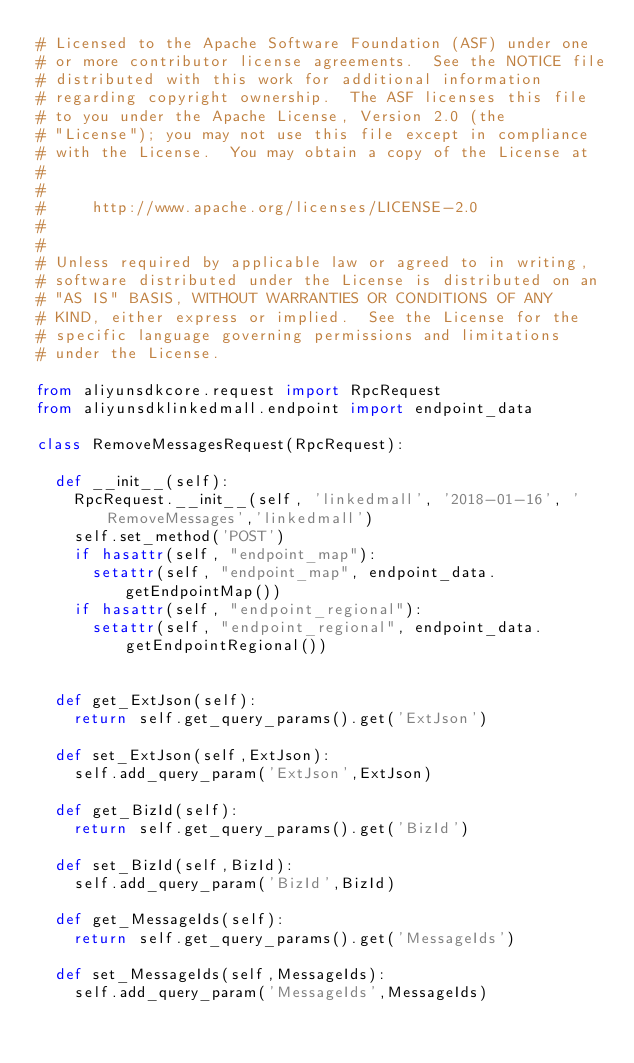<code> <loc_0><loc_0><loc_500><loc_500><_Python_># Licensed to the Apache Software Foundation (ASF) under one
# or more contributor license agreements.  See the NOTICE file
# distributed with this work for additional information
# regarding copyright ownership.  The ASF licenses this file
# to you under the Apache License, Version 2.0 (the
# "License"); you may not use this file except in compliance
# with the License.  You may obtain a copy of the License at
#
#
#     http://www.apache.org/licenses/LICENSE-2.0
#
#
# Unless required by applicable law or agreed to in writing,
# software distributed under the License is distributed on an
# "AS IS" BASIS, WITHOUT WARRANTIES OR CONDITIONS OF ANY
# KIND, either express or implied.  See the License for the
# specific language governing permissions and limitations
# under the License.

from aliyunsdkcore.request import RpcRequest
from aliyunsdklinkedmall.endpoint import endpoint_data

class RemoveMessagesRequest(RpcRequest):

	def __init__(self):
		RpcRequest.__init__(self, 'linkedmall', '2018-01-16', 'RemoveMessages','linkedmall')
		self.set_method('POST')
		if hasattr(self, "endpoint_map"):
			setattr(self, "endpoint_map", endpoint_data.getEndpointMap())
		if hasattr(self, "endpoint_regional"):
			setattr(self, "endpoint_regional", endpoint_data.getEndpointRegional())


	def get_ExtJson(self):
		return self.get_query_params().get('ExtJson')

	def set_ExtJson(self,ExtJson):
		self.add_query_param('ExtJson',ExtJson)

	def get_BizId(self):
		return self.get_query_params().get('BizId')

	def set_BizId(self,BizId):
		self.add_query_param('BizId',BizId)

	def get_MessageIds(self):
		return self.get_query_params().get('MessageIds')

	def set_MessageIds(self,MessageIds):
		self.add_query_param('MessageIds',MessageIds)</code> 